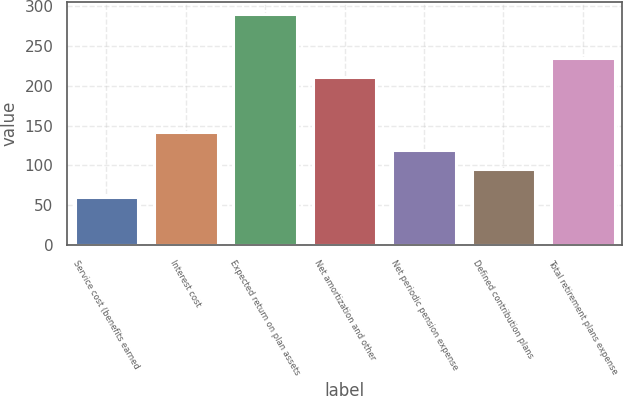<chart> <loc_0><loc_0><loc_500><loc_500><bar_chart><fcel>Service cost (benefits earned<fcel>Interest cost<fcel>Expected return on plan assets<fcel>Net amortization and other<fcel>Net periodic pension expense<fcel>Defined contribution plans<fcel>Total retirement plans expense<nl><fcel>60<fcel>142<fcel>290<fcel>211<fcel>119<fcel>96<fcel>234<nl></chart> 